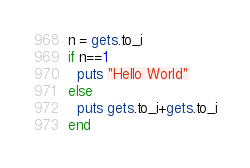Convert code to text. <code><loc_0><loc_0><loc_500><loc_500><_Ruby_>n = gets.to_i
if n==1
  puts "Hello World"
else
  puts gets.to_i+gets.to_i
end
</code> 